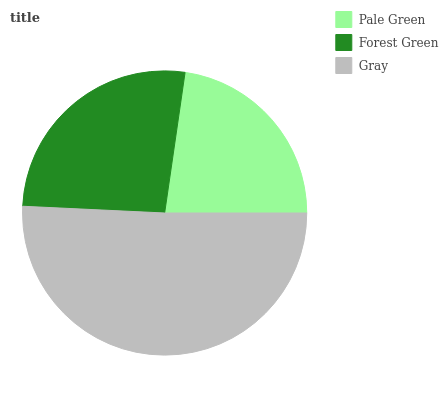Is Pale Green the minimum?
Answer yes or no. Yes. Is Gray the maximum?
Answer yes or no. Yes. Is Forest Green the minimum?
Answer yes or no. No. Is Forest Green the maximum?
Answer yes or no. No. Is Forest Green greater than Pale Green?
Answer yes or no. Yes. Is Pale Green less than Forest Green?
Answer yes or no. Yes. Is Pale Green greater than Forest Green?
Answer yes or no. No. Is Forest Green less than Pale Green?
Answer yes or no. No. Is Forest Green the high median?
Answer yes or no. Yes. Is Forest Green the low median?
Answer yes or no. Yes. Is Gray the high median?
Answer yes or no. No. Is Pale Green the low median?
Answer yes or no. No. 